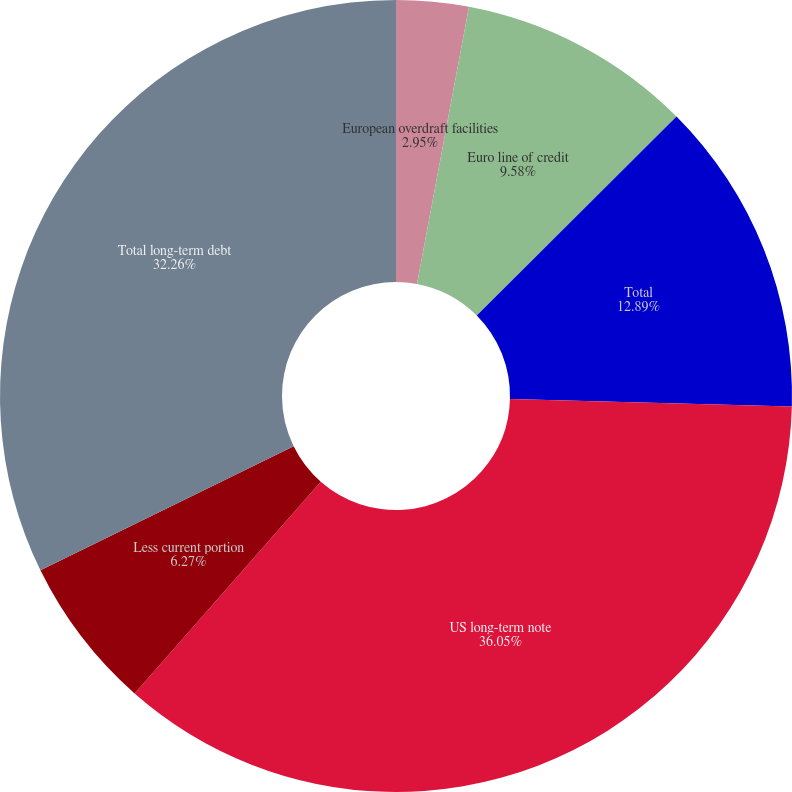Convert chart to OTSL. <chart><loc_0><loc_0><loc_500><loc_500><pie_chart><fcel>European overdraft facilities<fcel>Euro line of credit<fcel>Total<fcel>US long-term note<fcel>Less current portion<fcel>Total long-term debt<nl><fcel>2.95%<fcel>9.58%<fcel>12.89%<fcel>36.06%<fcel>6.27%<fcel>32.26%<nl></chart> 